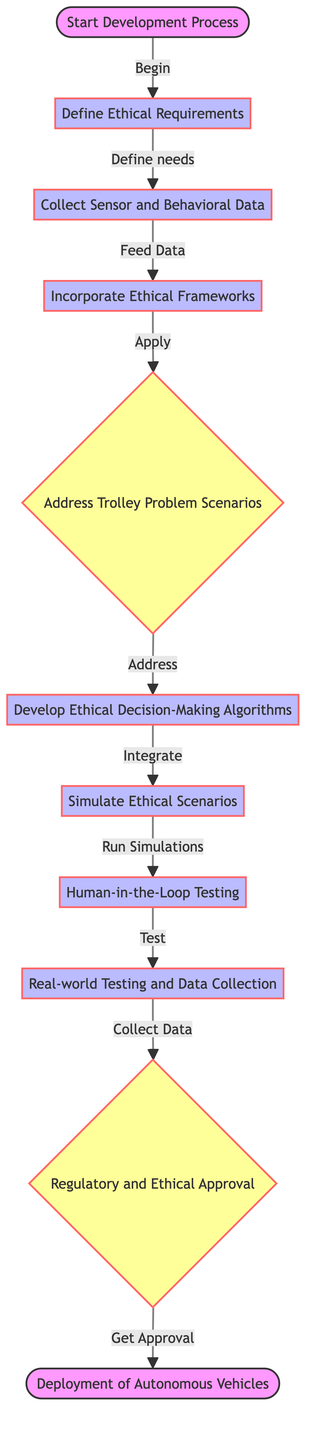What is the first step in the development process? The diagram indicates that the first step is "Start Development Process."
Answer: Start Development Process How many total nodes are present in the diagram? Counting the nodes listed, there are ten nodes in total, including "Start Development Process" and "Deployment of Autonomous Vehicles."
Answer: 10 What is the node directly connected to "Ethical Decision-Making Algorithms"? The diagram shows that "Simulation" is directly connected to "Ethical Decision-Making Algorithms."
Answer: Simulate Ethical Scenarios What type of node is "Trolley Problem Scenarios"? "Trolley Problem Scenarios" is represented as a decision node in the diagram, which is indicated by its unique shape compared to process nodes.
Answer: Decision What label is used for the edge leading from "Define Ethical Requirements" to "Collect Sensor and Behavioral Data"? The edge from "Define Ethical Requirements" to "Collect Sensor and Behavioral Data" is labeled as "Define needs."
Answer: Define needs Which two nodes are directly connected and describe testing activities? The nodes "Human-in-the-Loop Testing" and "Real-world Testing and Data Collection" are directly connected and both relate to testing activities.
Answer: Human-in-the-Loop Testing and Real-world Testing and Data Collection What is the last step before deployment in the process? According to the diagram, "Regulatory and Ethical Approval" is the last step before "Deployment of Autonomous Vehicles."
Answer: Regulatory and Ethical Approval What is the relationship between "Address Trolley Problem Scenarios" and "Develop Ethical Decision-Making Algorithms"? The relationship is that "Address Trolley Problem Scenarios" leads into the development of "Develop Ethical Decision-Making Algorithms," indicating that addressing trolley problems is a prerequisite for developing the algorithms.
Answer: Address How many edges connect the node "Real-world Testing and Data Collection"? The node "Real-world Testing and Data Collection" is connected by one edge leading to "Regulatory and Ethical Approval."
Answer: 1 